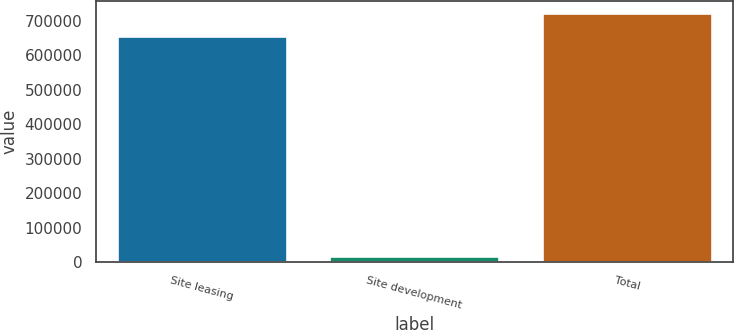Convert chart to OTSL. <chart><loc_0><loc_0><loc_500><loc_500><bar_chart><fcel>Site leasing<fcel>Site development<fcel>Total<nl><fcel>657143<fcel>17434<fcel>722857<nl></chart> 